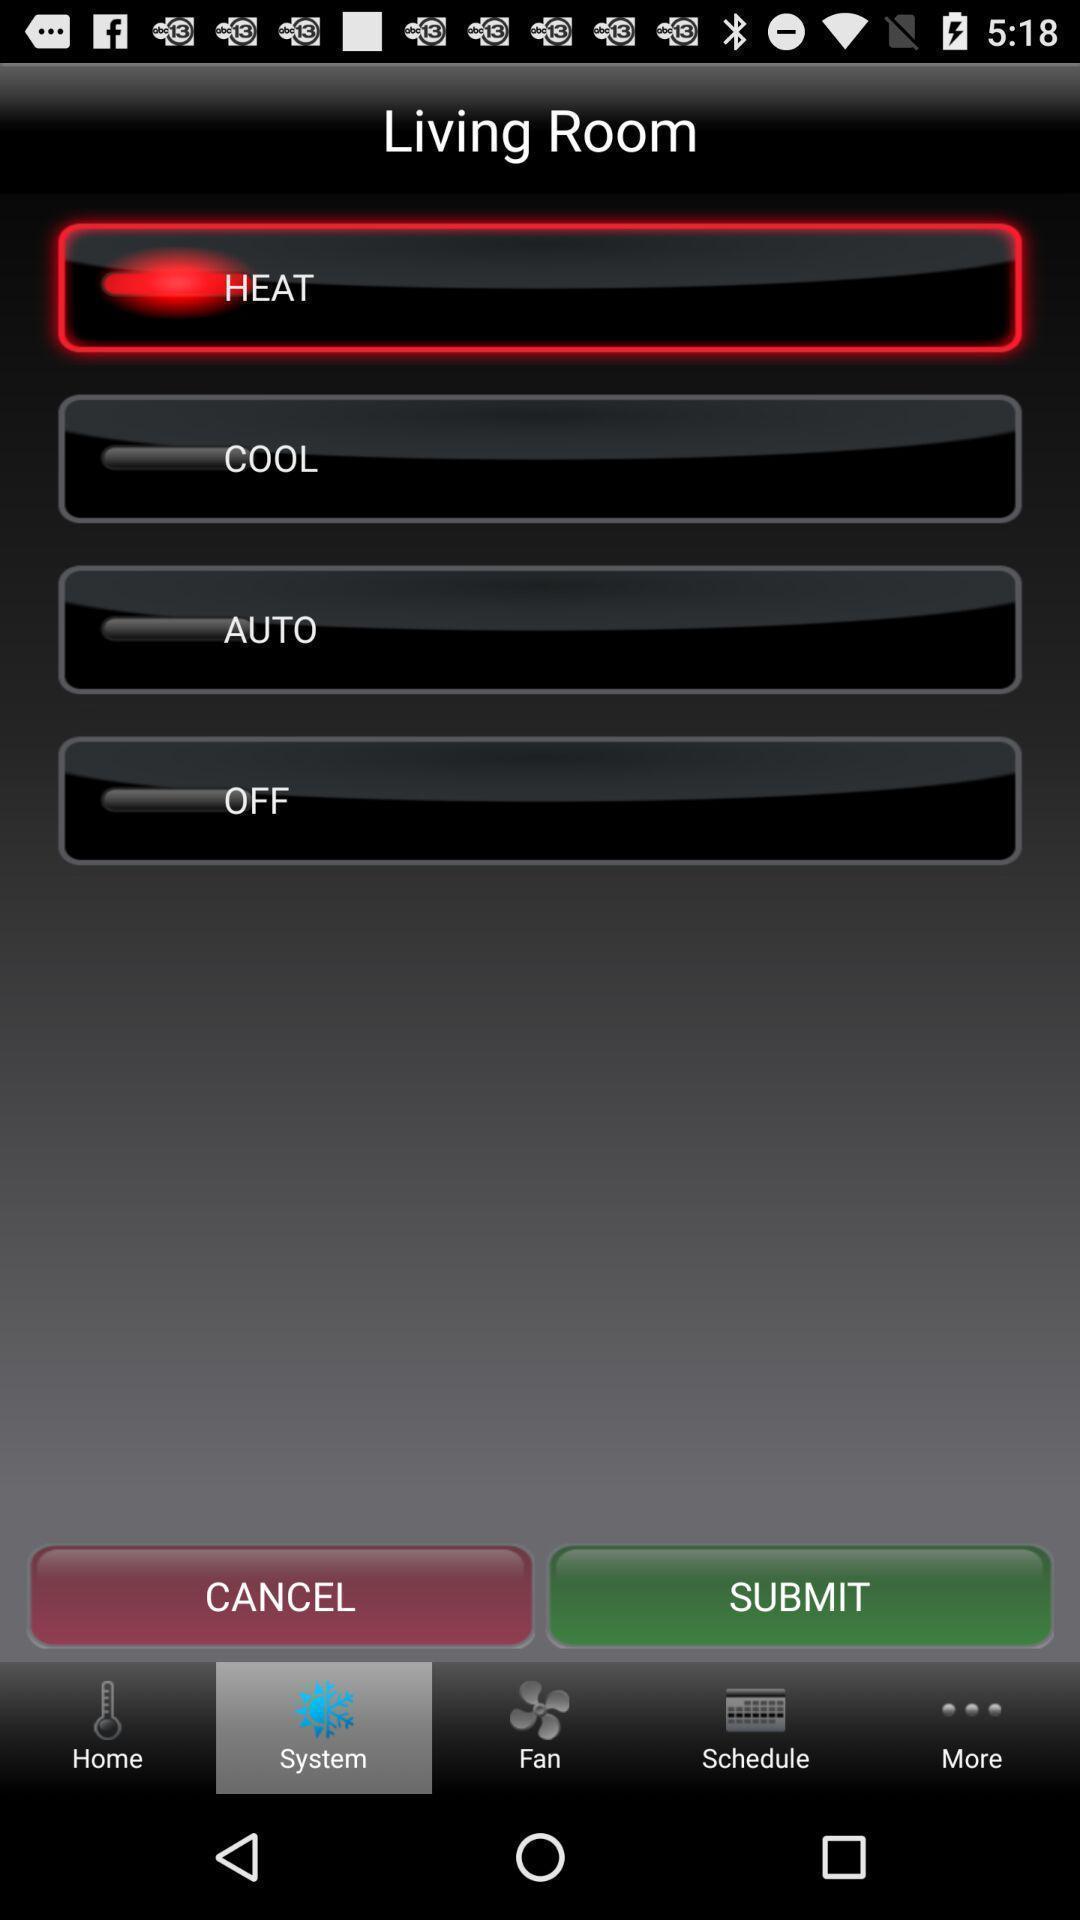Provide a description of this screenshot. Page showing living room options in the app. 